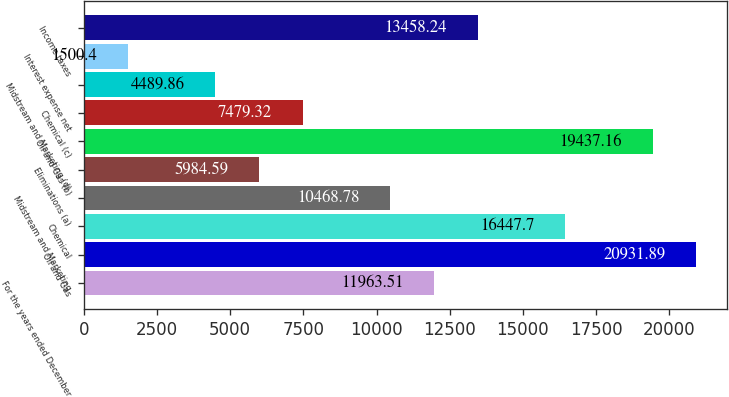Convert chart. <chart><loc_0><loc_0><loc_500><loc_500><bar_chart><fcel>For the years ended December<fcel>Oil and Gas<fcel>Chemical<fcel>Midstream and Marketing<fcel>Eliminations (a)<fcel>Oil and Gas (b)<fcel>Chemical (c)<fcel>Midstream and Marketing (d)<fcel>Interest expense net<fcel>Income taxes<nl><fcel>11963.5<fcel>20931.9<fcel>16447.7<fcel>10468.8<fcel>5984.59<fcel>19437.2<fcel>7479.32<fcel>4489.86<fcel>1500.4<fcel>13458.2<nl></chart> 